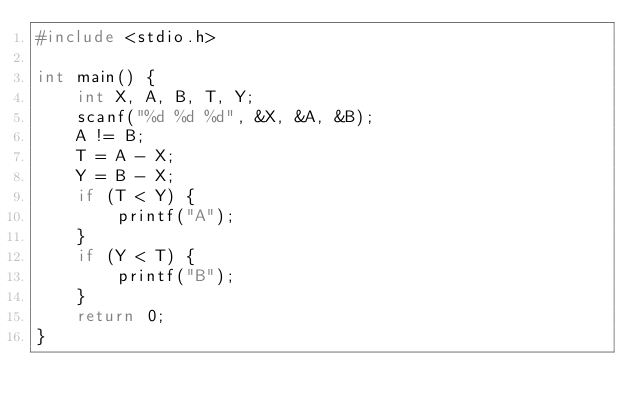Convert code to text. <code><loc_0><loc_0><loc_500><loc_500><_C_>#include <stdio.h>

int main() {
	int X, A, B, T, Y;
	scanf("%d %d %d", &X, &A, &B);
	A != B;
	T = A - X;
	Y = B - X;
	if (T < Y) {
		printf("A");
	} 
	if (Y < T) {
		printf("B");
	}
	return 0;
}</code> 